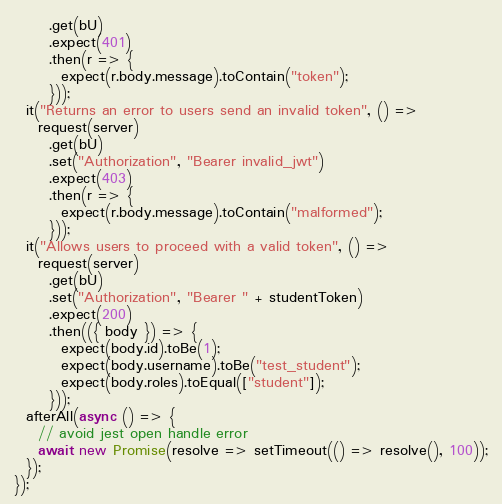Convert code to text. <code><loc_0><loc_0><loc_500><loc_500><_JavaScript_>      .get(bU)
      .expect(401)
      .then(r => {
        expect(r.body.message).toContain("token");
      }));
  it("Returns an error to users send an invalid token", () =>
    request(server)
      .get(bU)
      .set("Authorization", "Bearer invalid_jwt")
      .expect(403)
      .then(r => {
        expect(r.body.message).toContain("malformed");
      }));
  it("Allows users to proceed with a valid token", () =>
    request(server)
      .get(bU)
      .set("Authorization", "Bearer " + studentToken)
      .expect(200)
      .then(({ body }) => {
        expect(body.id).toBe(1);
        expect(body.username).toBe("test_student");
        expect(body.roles).toEqual(["student"]);
      }));
  afterAll(async () => {
    // avoid jest open handle error
    await new Promise(resolve => setTimeout(() => resolve(), 100));
  });
});
</code> 